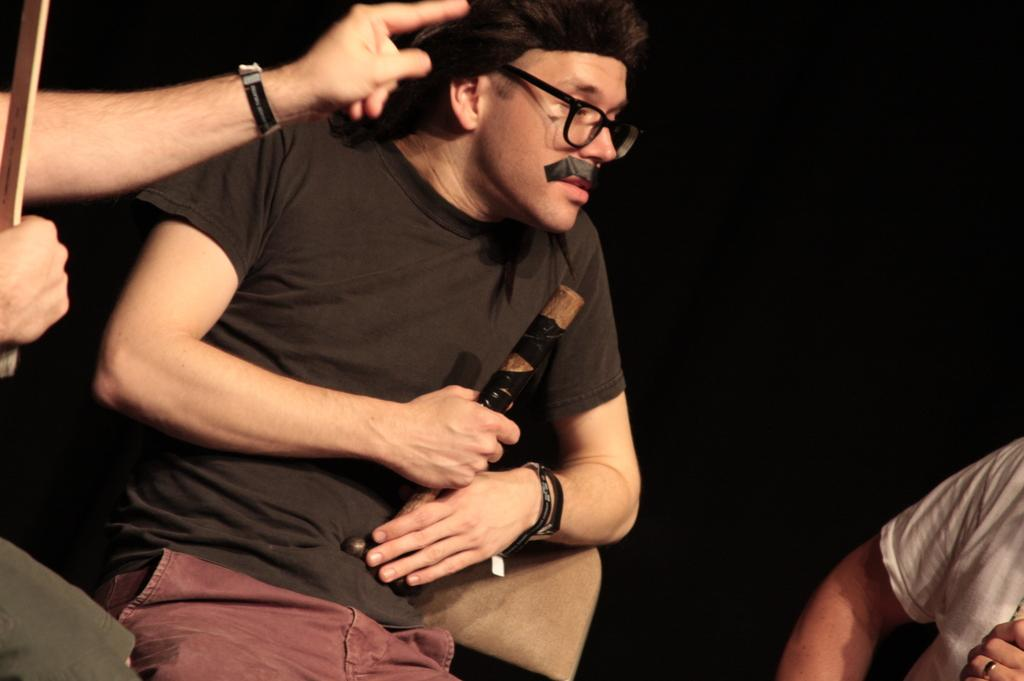How many people are in the image? There are three persons in the image. What is one person holding in the image? One person is holding a stick. Can you describe the appearance of the person holding the stick? The person holding the stick is wearing spectacles. What is the color of the background in the image? The background of the image is dark. What type of poison is being used by the person holding the stick in the image? There is no poison present in the image; the person is holding a stick and wearing spectacles. Can you tell me where the harbor is located in the image? There is no harbor present in the image; the background is dark, and the focus is on the three persons and the stick. 